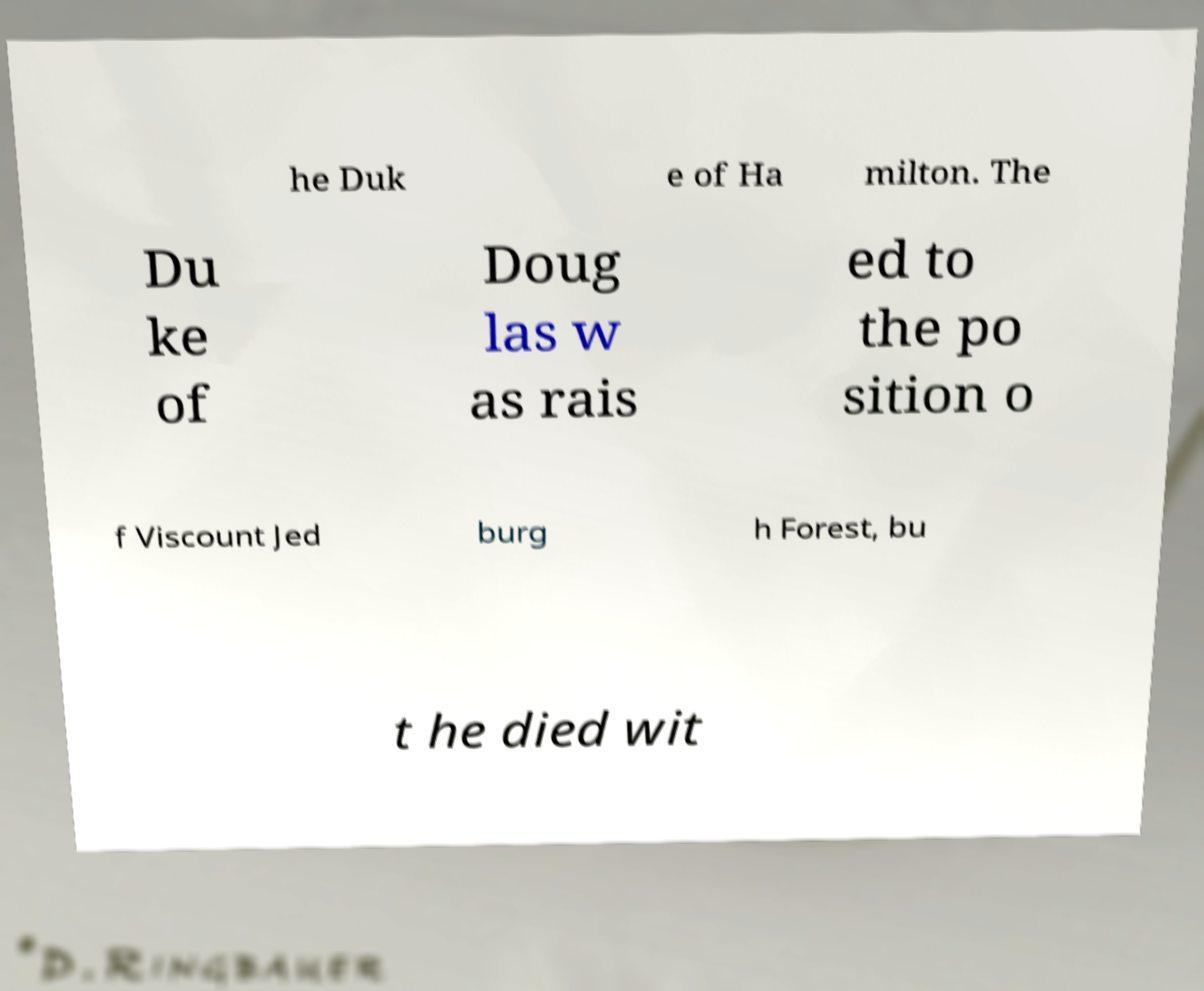There's text embedded in this image that I need extracted. Can you transcribe it verbatim? he Duk e of Ha milton. The Du ke of Doug las w as rais ed to the po sition o f Viscount Jed burg h Forest, bu t he died wit 